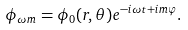<formula> <loc_0><loc_0><loc_500><loc_500>\phi _ { \omega m } = \phi _ { 0 } ( r , \theta ) e ^ { - i \omega t + i m \varphi } .</formula> 